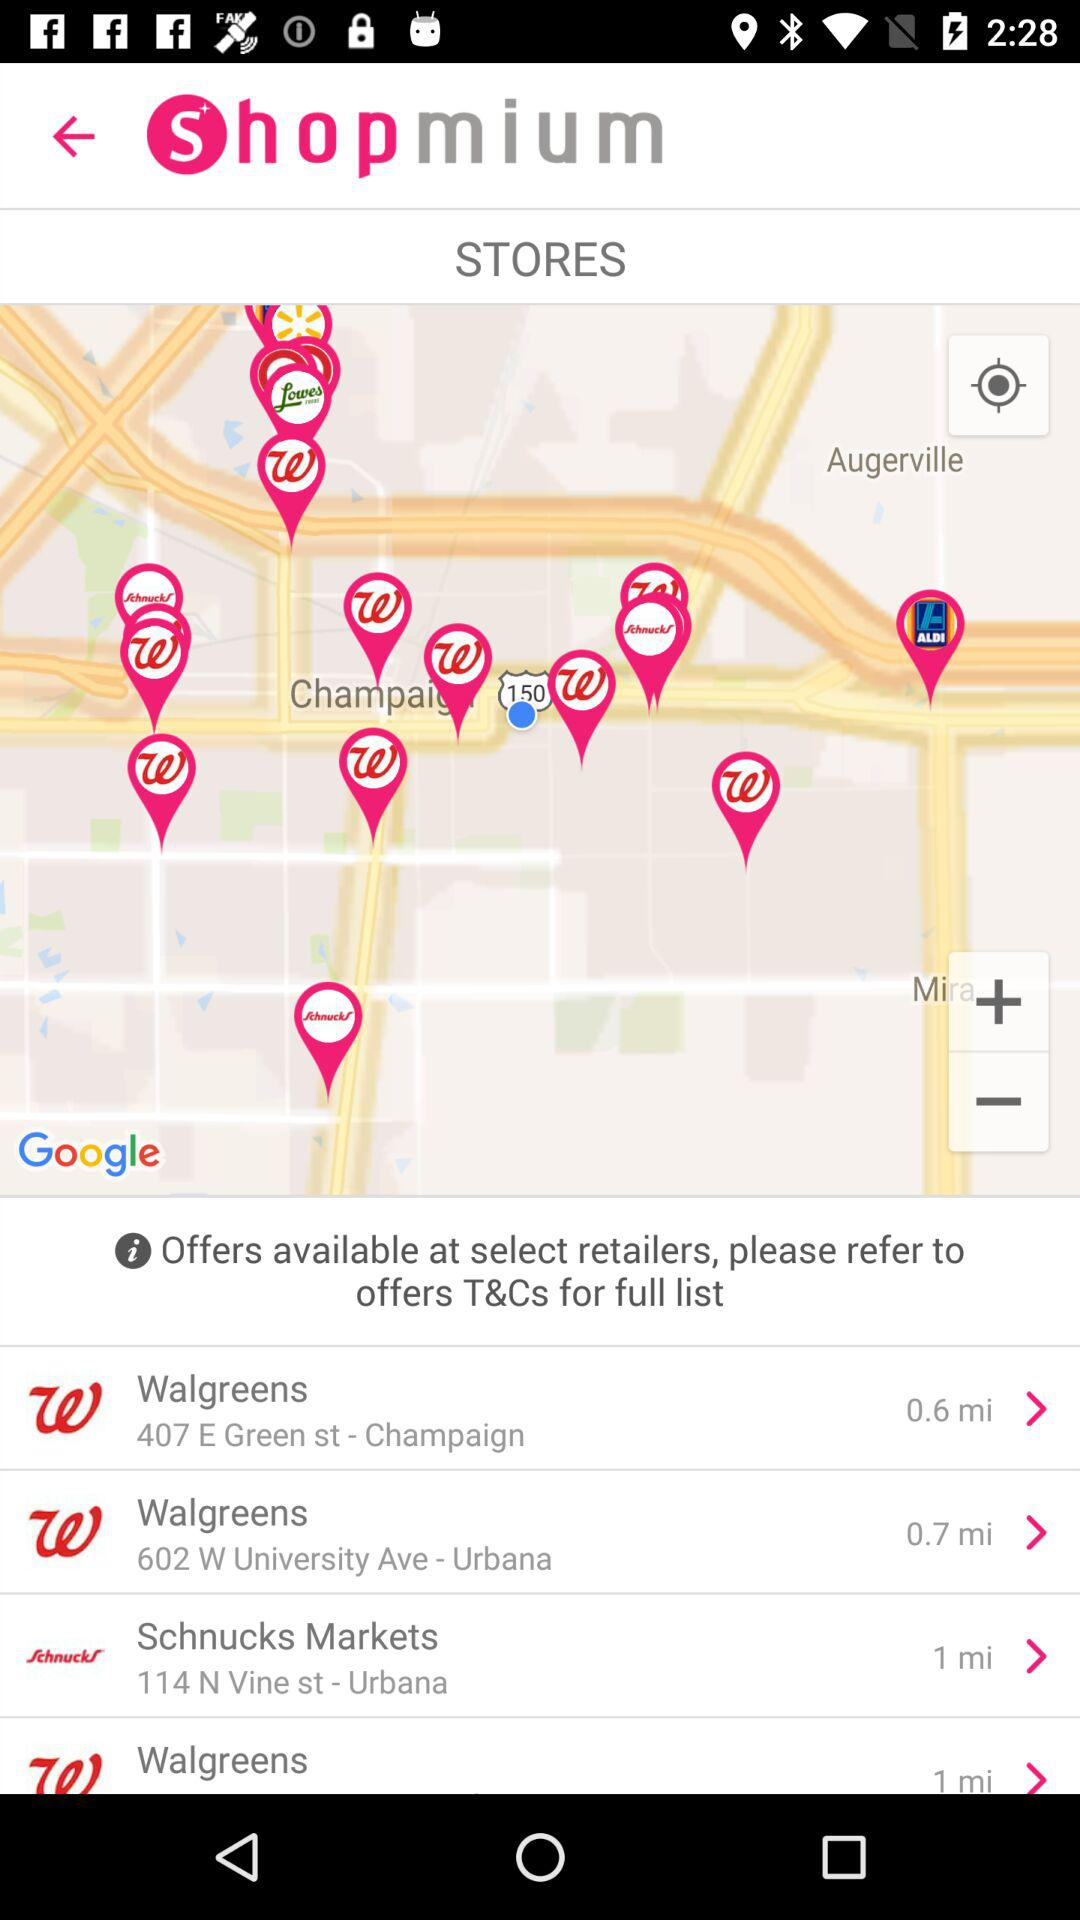Which of the stores is situated at a distance of 1 mile? The stores which are situated at a distance of 1 mile are "Schnucks Markets" and "Walgreens". 